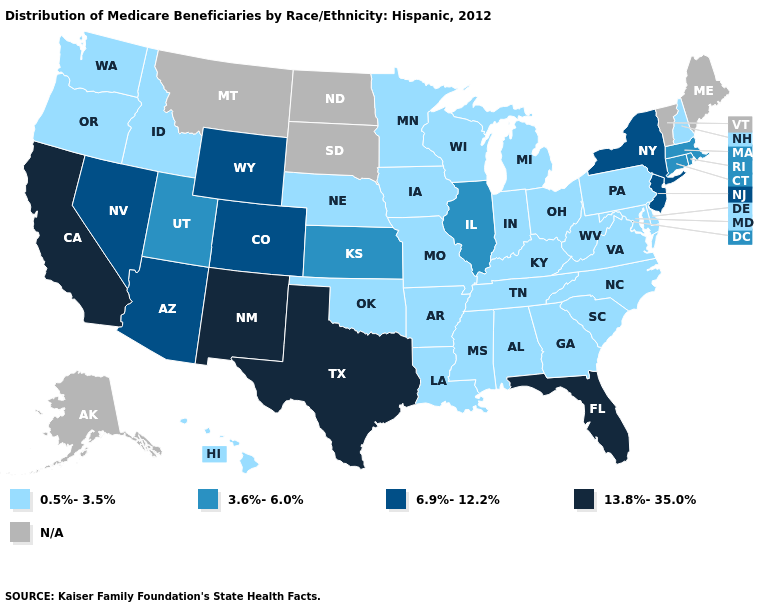Name the states that have a value in the range 0.5%-3.5%?
Quick response, please. Alabama, Arkansas, Delaware, Georgia, Hawaii, Idaho, Indiana, Iowa, Kentucky, Louisiana, Maryland, Michigan, Minnesota, Mississippi, Missouri, Nebraska, New Hampshire, North Carolina, Ohio, Oklahoma, Oregon, Pennsylvania, South Carolina, Tennessee, Virginia, Washington, West Virginia, Wisconsin. Which states hav the highest value in the West?
Short answer required. California, New Mexico. Among the states that border Nebraska , does Kansas have the lowest value?
Concise answer only. No. Among the states that border Arizona , which have the highest value?
Quick response, please. California, New Mexico. Does California have the highest value in the USA?
Write a very short answer. Yes. What is the value of Kentucky?
Give a very brief answer. 0.5%-3.5%. What is the highest value in the USA?
Be succinct. 13.8%-35.0%. Does Utah have the lowest value in the USA?
Write a very short answer. No. Which states have the lowest value in the MidWest?
Short answer required. Indiana, Iowa, Michigan, Minnesota, Missouri, Nebraska, Ohio, Wisconsin. Name the states that have a value in the range 0.5%-3.5%?
Quick response, please. Alabama, Arkansas, Delaware, Georgia, Hawaii, Idaho, Indiana, Iowa, Kentucky, Louisiana, Maryland, Michigan, Minnesota, Mississippi, Missouri, Nebraska, New Hampshire, North Carolina, Ohio, Oklahoma, Oregon, Pennsylvania, South Carolina, Tennessee, Virginia, Washington, West Virginia, Wisconsin. Name the states that have a value in the range 13.8%-35.0%?
Write a very short answer. California, Florida, New Mexico, Texas. What is the lowest value in the Northeast?
Concise answer only. 0.5%-3.5%. 